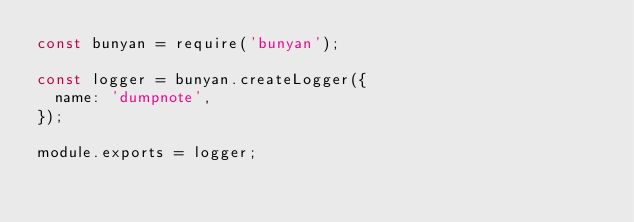<code> <loc_0><loc_0><loc_500><loc_500><_JavaScript_>const bunyan = require('bunyan');

const logger = bunyan.createLogger({
  name: 'dumpnote',
});

module.exports = logger;
</code> 